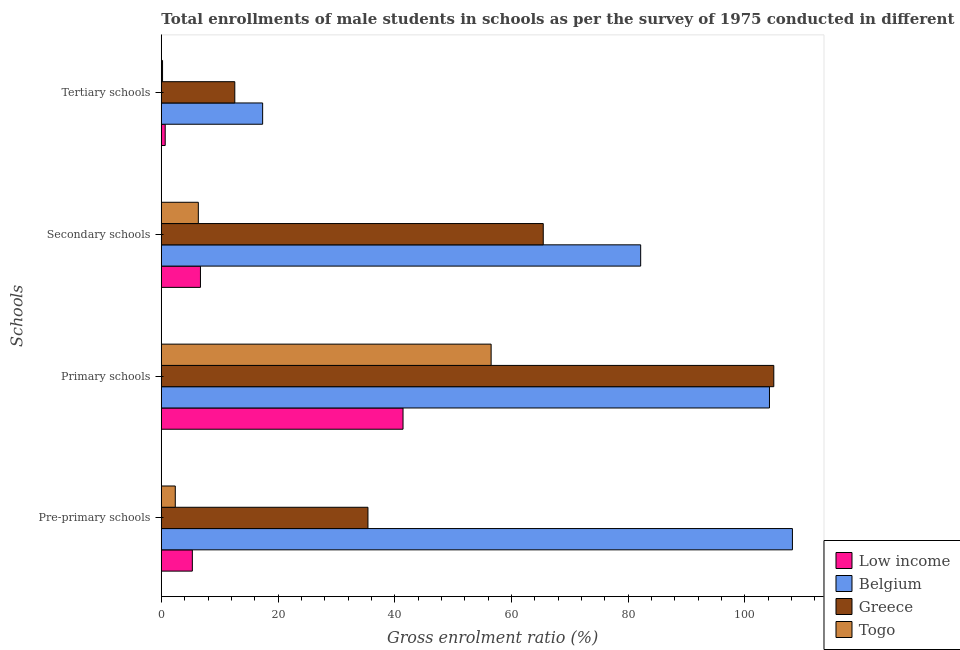How many different coloured bars are there?
Your answer should be compact. 4. How many bars are there on the 2nd tick from the top?
Keep it short and to the point. 4. How many bars are there on the 1st tick from the bottom?
Provide a succinct answer. 4. What is the label of the 4th group of bars from the top?
Your response must be concise. Pre-primary schools. What is the gross enrolment ratio(male) in tertiary schools in Belgium?
Ensure brevity in your answer.  17.37. Across all countries, what is the maximum gross enrolment ratio(male) in pre-primary schools?
Your response must be concise. 108.16. Across all countries, what is the minimum gross enrolment ratio(male) in pre-primary schools?
Your answer should be compact. 2.39. In which country was the gross enrolment ratio(male) in secondary schools maximum?
Provide a succinct answer. Belgium. What is the total gross enrolment ratio(male) in pre-primary schools in the graph?
Provide a succinct answer. 151.29. What is the difference between the gross enrolment ratio(male) in tertiary schools in Low income and that in Greece?
Make the answer very short. -11.93. What is the difference between the gross enrolment ratio(male) in primary schools in Belgium and the gross enrolment ratio(male) in secondary schools in Low income?
Your response must be concise. 97.52. What is the average gross enrolment ratio(male) in tertiary schools per country?
Provide a short and direct response. 7.71. What is the difference between the gross enrolment ratio(male) in pre-primary schools and gross enrolment ratio(male) in secondary schools in Togo?
Offer a terse response. -3.95. What is the ratio of the gross enrolment ratio(male) in secondary schools in Belgium to that in Togo?
Make the answer very short. 12.95. Is the gross enrolment ratio(male) in tertiary schools in Togo less than that in Low income?
Your response must be concise. Yes. Is the difference between the gross enrolment ratio(male) in tertiary schools in Greece and Low income greater than the difference between the gross enrolment ratio(male) in secondary schools in Greece and Low income?
Your answer should be compact. No. What is the difference between the highest and the second highest gross enrolment ratio(male) in secondary schools?
Give a very brief answer. 16.7. What is the difference between the highest and the lowest gross enrolment ratio(male) in primary schools?
Give a very brief answer. 63.54. Is it the case that in every country, the sum of the gross enrolment ratio(male) in tertiary schools and gross enrolment ratio(male) in pre-primary schools is greater than the sum of gross enrolment ratio(male) in primary schools and gross enrolment ratio(male) in secondary schools?
Your answer should be very brief. No. What does the 2nd bar from the top in Secondary schools represents?
Make the answer very short. Greece. Are all the bars in the graph horizontal?
Offer a terse response. Yes. How many countries are there in the graph?
Give a very brief answer. 4. Are the values on the major ticks of X-axis written in scientific E-notation?
Provide a short and direct response. No. What is the title of the graph?
Your answer should be very brief. Total enrollments of male students in schools as per the survey of 1975 conducted in different countries. What is the label or title of the X-axis?
Offer a very short reply. Gross enrolment ratio (%). What is the label or title of the Y-axis?
Offer a terse response. Schools. What is the Gross enrolment ratio (%) of Low income in Pre-primary schools?
Your answer should be very brief. 5.32. What is the Gross enrolment ratio (%) in Belgium in Pre-primary schools?
Ensure brevity in your answer.  108.16. What is the Gross enrolment ratio (%) of Greece in Pre-primary schools?
Offer a terse response. 35.41. What is the Gross enrolment ratio (%) in Togo in Pre-primary schools?
Keep it short and to the point. 2.39. What is the Gross enrolment ratio (%) of Low income in Primary schools?
Offer a terse response. 41.43. What is the Gross enrolment ratio (%) of Belgium in Primary schools?
Offer a terse response. 104.23. What is the Gross enrolment ratio (%) in Greece in Primary schools?
Provide a succinct answer. 104.97. What is the Gross enrolment ratio (%) in Togo in Primary schools?
Provide a short and direct response. 56.53. What is the Gross enrolment ratio (%) in Low income in Secondary schools?
Provide a succinct answer. 6.71. What is the Gross enrolment ratio (%) in Belgium in Secondary schools?
Your answer should be very brief. 82.16. What is the Gross enrolment ratio (%) in Greece in Secondary schools?
Ensure brevity in your answer.  65.46. What is the Gross enrolment ratio (%) in Togo in Secondary schools?
Offer a terse response. 6.34. What is the Gross enrolment ratio (%) in Low income in Tertiary schools?
Provide a short and direct response. 0.67. What is the Gross enrolment ratio (%) in Belgium in Tertiary schools?
Your answer should be very brief. 17.37. What is the Gross enrolment ratio (%) of Greece in Tertiary schools?
Your answer should be very brief. 12.59. What is the Gross enrolment ratio (%) in Togo in Tertiary schools?
Give a very brief answer. 0.21. Across all Schools, what is the maximum Gross enrolment ratio (%) of Low income?
Offer a terse response. 41.43. Across all Schools, what is the maximum Gross enrolment ratio (%) in Belgium?
Your answer should be very brief. 108.16. Across all Schools, what is the maximum Gross enrolment ratio (%) of Greece?
Provide a short and direct response. 104.97. Across all Schools, what is the maximum Gross enrolment ratio (%) in Togo?
Your response must be concise. 56.53. Across all Schools, what is the minimum Gross enrolment ratio (%) in Low income?
Provide a short and direct response. 0.67. Across all Schools, what is the minimum Gross enrolment ratio (%) of Belgium?
Your answer should be very brief. 17.37. Across all Schools, what is the minimum Gross enrolment ratio (%) of Greece?
Ensure brevity in your answer.  12.59. Across all Schools, what is the minimum Gross enrolment ratio (%) of Togo?
Keep it short and to the point. 0.21. What is the total Gross enrolment ratio (%) of Low income in the graph?
Offer a very short reply. 54.12. What is the total Gross enrolment ratio (%) of Belgium in the graph?
Offer a very short reply. 311.91. What is the total Gross enrolment ratio (%) of Greece in the graph?
Your response must be concise. 218.43. What is the total Gross enrolment ratio (%) in Togo in the graph?
Your answer should be very brief. 65.47. What is the difference between the Gross enrolment ratio (%) of Low income in Pre-primary schools and that in Primary schools?
Keep it short and to the point. -36.11. What is the difference between the Gross enrolment ratio (%) of Belgium in Pre-primary schools and that in Primary schools?
Provide a succinct answer. 3.93. What is the difference between the Gross enrolment ratio (%) of Greece in Pre-primary schools and that in Primary schools?
Your answer should be very brief. -69.55. What is the difference between the Gross enrolment ratio (%) in Togo in Pre-primary schools and that in Primary schools?
Keep it short and to the point. -54.13. What is the difference between the Gross enrolment ratio (%) in Low income in Pre-primary schools and that in Secondary schools?
Make the answer very short. -1.39. What is the difference between the Gross enrolment ratio (%) in Belgium in Pre-primary schools and that in Secondary schools?
Provide a succinct answer. 26.01. What is the difference between the Gross enrolment ratio (%) of Greece in Pre-primary schools and that in Secondary schools?
Provide a succinct answer. -30.04. What is the difference between the Gross enrolment ratio (%) in Togo in Pre-primary schools and that in Secondary schools?
Make the answer very short. -3.95. What is the difference between the Gross enrolment ratio (%) in Low income in Pre-primary schools and that in Tertiary schools?
Make the answer very short. 4.65. What is the difference between the Gross enrolment ratio (%) in Belgium in Pre-primary schools and that in Tertiary schools?
Offer a terse response. 90.79. What is the difference between the Gross enrolment ratio (%) in Greece in Pre-primary schools and that in Tertiary schools?
Keep it short and to the point. 22.82. What is the difference between the Gross enrolment ratio (%) of Togo in Pre-primary schools and that in Tertiary schools?
Provide a short and direct response. 2.18. What is the difference between the Gross enrolment ratio (%) of Low income in Primary schools and that in Secondary schools?
Offer a terse response. 34.72. What is the difference between the Gross enrolment ratio (%) in Belgium in Primary schools and that in Secondary schools?
Offer a terse response. 22.07. What is the difference between the Gross enrolment ratio (%) of Greece in Primary schools and that in Secondary schools?
Make the answer very short. 39.51. What is the difference between the Gross enrolment ratio (%) in Togo in Primary schools and that in Secondary schools?
Offer a terse response. 50.18. What is the difference between the Gross enrolment ratio (%) of Low income in Primary schools and that in Tertiary schools?
Offer a terse response. 40.76. What is the difference between the Gross enrolment ratio (%) of Belgium in Primary schools and that in Tertiary schools?
Your response must be concise. 86.86. What is the difference between the Gross enrolment ratio (%) in Greece in Primary schools and that in Tertiary schools?
Provide a succinct answer. 92.38. What is the difference between the Gross enrolment ratio (%) in Togo in Primary schools and that in Tertiary schools?
Your response must be concise. 56.32. What is the difference between the Gross enrolment ratio (%) in Low income in Secondary schools and that in Tertiary schools?
Give a very brief answer. 6.04. What is the difference between the Gross enrolment ratio (%) of Belgium in Secondary schools and that in Tertiary schools?
Give a very brief answer. 64.79. What is the difference between the Gross enrolment ratio (%) in Greece in Secondary schools and that in Tertiary schools?
Your response must be concise. 52.87. What is the difference between the Gross enrolment ratio (%) of Togo in Secondary schools and that in Tertiary schools?
Give a very brief answer. 6.13. What is the difference between the Gross enrolment ratio (%) in Low income in Pre-primary schools and the Gross enrolment ratio (%) in Belgium in Primary schools?
Keep it short and to the point. -98.91. What is the difference between the Gross enrolment ratio (%) of Low income in Pre-primary schools and the Gross enrolment ratio (%) of Greece in Primary schools?
Your answer should be very brief. -99.65. What is the difference between the Gross enrolment ratio (%) in Low income in Pre-primary schools and the Gross enrolment ratio (%) in Togo in Primary schools?
Your response must be concise. -51.21. What is the difference between the Gross enrolment ratio (%) of Belgium in Pre-primary schools and the Gross enrolment ratio (%) of Greece in Primary schools?
Your response must be concise. 3.19. What is the difference between the Gross enrolment ratio (%) of Belgium in Pre-primary schools and the Gross enrolment ratio (%) of Togo in Primary schools?
Give a very brief answer. 51.64. What is the difference between the Gross enrolment ratio (%) of Greece in Pre-primary schools and the Gross enrolment ratio (%) of Togo in Primary schools?
Ensure brevity in your answer.  -21.11. What is the difference between the Gross enrolment ratio (%) of Low income in Pre-primary schools and the Gross enrolment ratio (%) of Belgium in Secondary schools?
Offer a very short reply. -76.84. What is the difference between the Gross enrolment ratio (%) of Low income in Pre-primary schools and the Gross enrolment ratio (%) of Greece in Secondary schools?
Offer a very short reply. -60.14. What is the difference between the Gross enrolment ratio (%) of Low income in Pre-primary schools and the Gross enrolment ratio (%) of Togo in Secondary schools?
Offer a terse response. -1.02. What is the difference between the Gross enrolment ratio (%) of Belgium in Pre-primary schools and the Gross enrolment ratio (%) of Greece in Secondary schools?
Give a very brief answer. 42.7. What is the difference between the Gross enrolment ratio (%) of Belgium in Pre-primary schools and the Gross enrolment ratio (%) of Togo in Secondary schools?
Offer a terse response. 101.82. What is the difference between the Gross enrolment ratio (%) of Greece in Pre-primary schools and the Gross enrolment ratio (%) of Togo in Secondary schools?
Give a very brief answer. 29.07. What is the difference between the Gross enrolment ratio (%) of Low income in Pre-primary schools and the Gross enrolment ratio (%) of Belgium in Tertiary schools?
Provide a succinct answer. -12.05. What is the difference between the Gross enrolment ratio (%) in Low income in Pre-primary schools and the Gross enrolment ratio (%) in Greece in Tertiary schools?
Give a very brief answer. -7.27. What is the difference between the Gross enrolment ratio (%) of Low income in Pre-primary schools and the Gross enrolment ratio (%) of Togo in Tertiary schools?
Keep it short and to the point. 5.11. What is the difference between the Gross enrolment ratio (%) of Belgium in Pre-primary schools and the Gross enrolment ratio (%) of Greece in Tertiary schools?
Offer a very short reply. 95.57. What is the difference between the Gross enrolment ratio (%) of Belgium in Pre-primary schools and the Gross enrolment ratio (%) of Togo in Tertiary schools?
Provide a short and direct response. 107.95. What is the difference between the Gross enrolment ratio (%) of Greece in Pre-primary schools and the Gross enrolment ratio (%) of Togo in Tertiary schools?
Give a very brief answer. 35.2. What is the difference between the Gross enrolment ratio (%) of Low income in Primary schools and the Gross enrolment ratio (%) of Belgium in Secondary schools?
Give a very brief answer. -40.73. What is the difference between the Gross enrolment ratio (%) of Low income in Primary schools and the Gross enrolment ratio (%) of Greece in Secondary schools?
Provide a succinct answer. -24.03. What is the difference between the Gross enrolment ratio (%) in Low income in Primary schools and the Gross enrolment ratio (%) in Togo in Secondary schools?
Provide a short and direct response. 35.08. What is the difference between the Gross enrolment ratio (%) of Belgium in Primary schools and the Gross enrolment ratio (%) of Greece in Secondary schools?
Offer a very short reply. 38.77. What is the difference between the Gross enrolment ratio (%) in Belgium in Primary schools and the Gross enrolment ratio (%) in Togo in Secondary schools?
Provide a short and direct response. 97.88. What is the difference between the Gross enrolment ratio (%) of Greece in Primary schools and the Gross enrolment ratio (%) of Togo in Secondary schools?
Offer a terse response. 98.63. What is the difference between the Gross enrolment ratio (%) in Low income in Primary schools and the Gross enrolment ratio (%) in Belgium in Tertiary schools?
Keep it short and to the point. 24.06. What is the difference between the Gross enrolment ratio (%) in Low income in Primary schools and the Gross enrolment ratio (%) in Greece in Tertiary schools?
Your response must be concise. 28.83. What is the difference between the Gross enrolment ratio (%) of Low income in Primary schools and the Gross enrolment ratio (%) of Togo in Tertiary schools?
Your answer should be compact. 41.22. What is the difference between the Gross enrolment ratio (%) of Belgium in Primary schools and the Gross enrolment ratio (%) of Greece in Tertiary schools?
Keep it short and to the point. 91.63. What is the difference between the Gross enrolment ratio (%) in Belgium in Primary schools and the Gross enrolment ratio (%) in Togo in Tertiary schools?
Keep it short and to the point. 104.02. What is the difference between the Gross enrolment ratio (%) of Greece in Primary schools and the Gross enrolment ratio (%) of Togo in Tertiary schools?
Make the answer very short. 104.76. What is the difference between the Gross enrolment ratio (%) in Low income in Secondary schools and the Gross enrolment ratio (%) in Belgium in Tertiary schools?
Provide a short and direct response. -10.66. What is the difference between the Gross enrolment ratio (%) of Low income in Secondary schools and the Gross enrolment ratio (%) of Greece in Tertiary schools?
Your answer should be very brief. -5.89. What is the difference between the Gross enrolment ratio (%) in Low income in Secondary schools and the Gross enrolment ratio (%) in Togo in Tertiary schools?
Make the answer very short. 6.5. What is the difference between the Gross enrolment ratio (%) of Belgium in Secondary schools and the Gross enrolment ratio (%) of Greece in Tertiary schools?
Provide a succinct answer. 69.56. What is the difference between the Gross enrolment ratio (%) of Belgium in Secondary schools and the Gross enrolment ratio (%) of Togo in Tertiary schools?
Ensure brevity in your answer.  81.95. What is the difference between the Gross enrolment ratio (%) of Greece in Secondary schools and the Gross enrolment ratio (%) of Togo in Tertiary schools?
Ensure brevity in your answer.  65.25. What is the average Gross enrolment ratio (%) in Low income per Schools?
Make the answer very short. 13.53. What is the average Gross enrolment ratio (%) of Belgium per Schools?
Your response must be concise. 77.98. What is the average Gross enrolment ratio (%) of Greece per Schools?
Make the answer very short. 54.61. What is the average Gross enrolment ratio (%) in Togo per Schools?
Your answer should be compact. 16.37. What is the difference between the Gross enrolment ratio (%) in Low income and Gross enrolment ratio (%) in Belgium in Pre-primary schools?
Your answer should be compact. -102.84. What is the difference between the Gross enrolment ratio (%) of Low income and Gross enrolment ratio (%) of Greece in Pre-primary schools?
Offer a very short reply. -30.1. What is the difference between the Gross enrolment ratio (%) of Low income and Gross enrolment ratio (%) of Togo in Pre-primary schools?
Provide a short and direct response. 2.92. What is the difference between the Gross enrolment ratio (%) in Belgium and Gross enrolment ratio (%) in Greece in Pre-primary schools?
Offer a very short reply. 72.75. What is the difference between the Gross enrolment ratio (%) in Belgium and Gross enrolment ratio (%) in Togo in Pre-primary schools?
Give a very brief answer. 105.77. What is the difference between the Gross enrolment ratio (%) of Greece and Gross enrolment ratio (%) of Togo in Pre-primary schools?
Offer a terse response. 33.02. What is the difference between the Gross enrolment ratio (%) of Low income and Gross enrolment ratio (%) of Belgium in Primary schools?
Your response must be concise. -62.8. What is the difference between the Gross enrolment ratio (%) in Low income and Gross enrolment ratio (%) in Greece in Primary schools?
Ensure brevity in your answer.  -63.54. What is the difference between the Gross enrolment ratio (%) of Low income and Gross enrolment ratio (%) of Togo in Primary schools?
Keep it short and to the point. -15.1. What is the difference between the Gross enrolment ratio (%) of Belgium and Gross enrolment ratio (%) of Greece in Primary schools?
Make the answer very short. -0.74. What is the difference between the Gross enrolment ratio (%) in Belgium and Gross enrolment ratio (%) in Togo in Primary schools?
Give a very brief answer. 47.7. What is the difference between the Gross enrolment ratio (%) of Greece and Gross enrolment ratio (%) of Togo in Primary schools?
Provide a short and direct response. 48.44. What is the difference between the Gross enrolment ratio (%) of Low income and Gross enrolment ratio (%) of Belgium in Secondary schools?
Provide a succinct answer. -75.45. What is the difference between the Gross enrolment ratio (%) in Low income and Gross enrolment ratio (%) in Greece in Secondary schools?
Offer a very short reply. -58.75. What is the difference between the Gross enrolment ratio (%) in Low income and Gross enrolment ratio (%) in Togo in Secondary schools?
Offer a terse response. 0.36. What is the difference between the Gross enrolment ratio (%) in Belgium and Gross enrolment ratio (%) in Greece in Secondary schools?
Your answer should be very brief. 16.7. What is the difference between the Gross enrolment ratio (%) of Belgium and Gross enrolment ratio (%) of Togo in Secondary schools?
Make the answer very short. 75.81. What is the difference between the Gross enrolment ratio (%) in Greece and Gross enrolment ratio (%) in Togo in Secondary schools?
Offer a very short reply. 59.12. What is the difference between the Gross enrolment ratio (%) of Low income and Gross enrolment ratio (%) of Belgium in Tertiary schools?
Offer a very short reply. -16.7. What is the difference between the Gross enrolment ratio (%) in Low income and Gross enrolment ratio (%) in Greece in Tertiary schools?
Give a very brief answer. -11.93. What is the difference between the Gross enrolment ratio (%) of Low income and Gross enrolment ratio (%) of Togo in Tertiary schools?
Ensure brevity in your answer.  0.46. What is the difference between the Gross enrolment ratio (%) of Belgium and Gross enrolment ratio (%) of Greece in Tertiary schools?
Make the answer very short. 4.77. What is the difference between the Gross enrolment ratio (%) in Belgium and Gross enrolment ratio (%) in Togo in Tertiary schools?
Provide a succinct answer. 17.16. What is the difference between the Gross enrolment ratio (%) of Greece and Gross enrolment ratio (%) of Togo in Tertiary schools?
Ensure brevity in your answer.  12.38. What is the ratio of the Gross enrolment ratio (%) of Low income in Pre-primary schools to that in Primary schools?
Give a very brief answer. 0.13. What is the ratio of the Gross enrolment ratio (%) of Belgium in Pre-primary schools to that in Primary schools?
Keep it short and to the point. 1.04. What is the ratio of the Gross enrolment ratio (%) in Greece in Pre-primary schools to that in Primary schools?
Make the answer very short. 0.34. What is the ratio of the Gross enrolment ratio (%) of Togo in Pre-primary schools to that in Primary schools?
Provide a succinct answer. 0.04. What is the ratio of the Gross enrolment ratio (%) in Low income in Pre-primary schools to that in Secondary schools?
Your response must be concise. 0.79. What is the ratio of the Gross enrolment ratio (%) in Belgium in Pre-primary schools to that in Secondary schools?
Provide a short and direct response. 1.32. What is the ratio of the Gross enrolment ratio (%) of Greece in Pre-primary schools to that in Secondary schools?
Keep it short and to the point. 0.54. What is the ratio of the Gross enrolment ratio (%) of Togo in Pre-primary schools to that in Secondary schools?
Ensure brevity in your answer.  0.38. What is the ratio of the Gross enrolment ratio (%) of Low income in Pre-primary schools to that in Tertiary schools?
Offer a terse response. 7.99. What is the ratio of the Gross enrolment ratio (%) of Belgium in Pre-primary schools to that in Tertiary schools?
Your answer should be very brief. 6.23. What is the ratio of the Gross enrolment ratio (%) in Greece in Pre-primary schools to that in Tertiary schools?
Offer a very short reply. 2.81. What is the ratio of the Gross enrolment ratio (%) of Togo in Pre-primary schools to that in Tertiary schools?
Give a very brief answer. 11.41. What is the ratio of the Gross enrolment ratio (%) in Low income in Primary schools to that in Secondary schools?
Provide a short and direct response. 6.18. What is the ratio of the Gross enrolment ratio (%) in Belgium in Primary schools to that in Secondary schools?
Offer a very short reply. 1.27. What is the ratio of the Gross enrolment ratio (%) in Greece in Primary schools to that in Secondary schools?
Provide a short and direct response. 1.6. What is the ratio of the Gross enrolment ratio (%) of Togo in Primary schools to that in Secondary schools?
Keep it short and to the point. 8.91. What is the ratio of the Gross enrolment ratio (%) in Low income in Primary schools to that in Tertiary schools?
Your answer should be compact. 62.22. What is the ratio of the Gross enrolment ratio (%) in Belgium in Primary schools to that in Tertiary schools?
Make the answer very short. 6. What is the ratio of the Gross enrolment ratio (%) of Greece in Primary schools to that in Tertiary schools?
Give a very brief answer. 8.34. What is the ratio of the Gross enrolment ratio (%) in Togo in Primary schools to that in Tertiary schools?
Ensure brevity in your answer.  269.36. What is the ratio of the Gross enrolment ratio (%) in Low income in Secondary schools to that in Tertiary schools?
Offer a terse response. 10.07. What is the ratio of the Gross enrolment ratio (%) of Belgium in Secondary schools to that in Tertiary schools?
Keep it short and to the point. 4.73. What is the ratio of the Gross enrolment ratio (%) in Greece in Secondary schools to that in Tertiary schools?
Your response must be concise. 5.2. What is the ratio of the Gross enrolment ratio (%) of Togo in Secondary schools to that in Tertiary schools?
Keep it short and to the point. 30.22. What is the difference between the highest and the second highest Gross enrolment ratio (%) of Low income?
Your answer should be very brief. 34.72. What is the difference between the highest and the second highest Gross enrolment ratio (%) in Belgium?
Give a very brief answer. 3.93. What is the difference between the highest and the second highest Gross enrolment ratio (%) of Greece?
Provide a short and direct response. 39.51. What is the difference between the highest and the second highest Gross enrolment ratio (%) of Togo?
Make the answer very short. 50.18. What is the difference between the highest and the lowest Gross enrolment ratio (%) of Low income?
Offer a terse response. 40.76. What is the difference between the highest and the lowest Gross enrolment ratio (%) in Belgium?
Offer a very short reply. 90.79. What is the difference between the highest and the lowest Gross enrolment ratio (%) in Greece?
Provide a short and direct response. 92.38. What is the difference between the highest and the lowest Gross enrolment ratio (%) in Togo?
Ensure brevity in your answer.  56.32. 